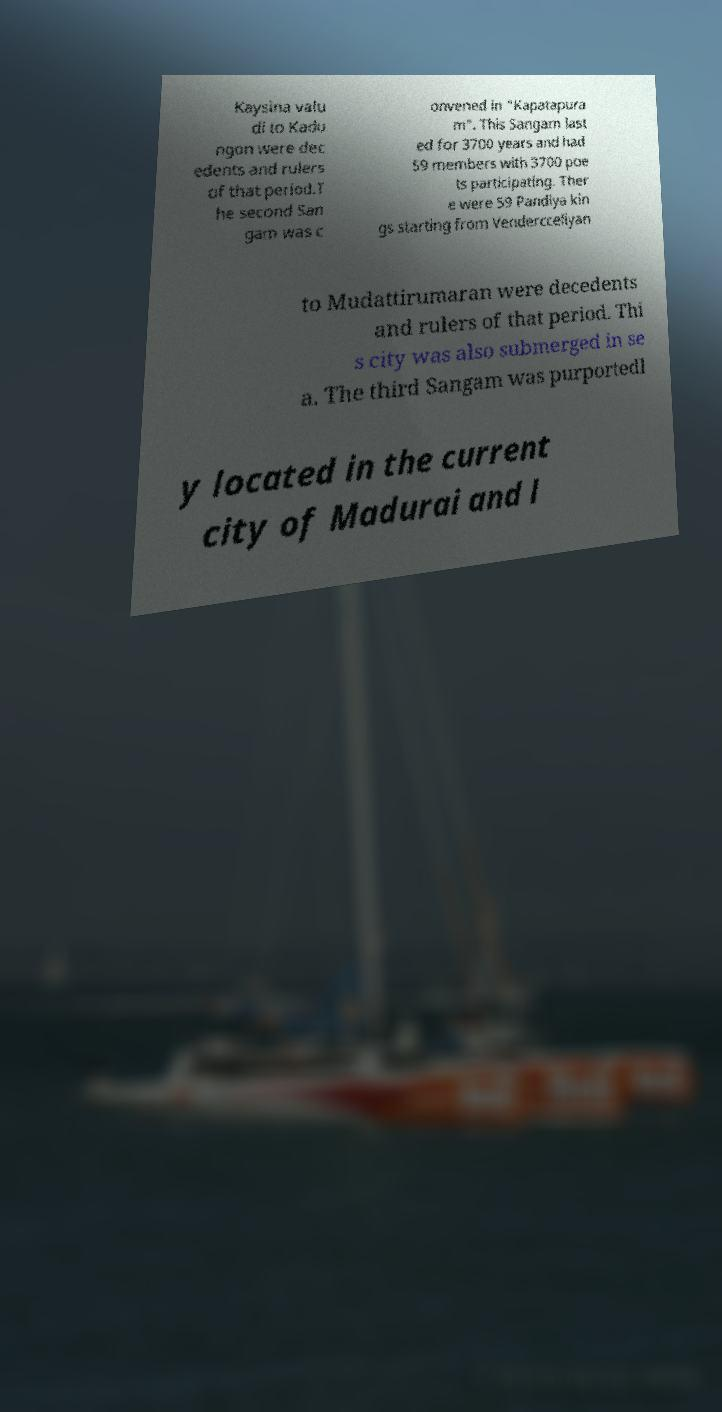For documentation purposes, I need the text within this image transcribed. Could you provide that? Kaysina valu di to Kadu ngon were dec edents and rulers of that period.T he second San gam was c onvened in "Kapatapura m". This Sangam last ed for 3700 years and had 59 members with 3700 poe ts participating. Ther e were 59 Pandiya kin gs starting from Vendercceliyan to Mudattirumaran were decedents and rulers of that period. Thi s city was also submerged in se a. The third Sangam was purportedl y located in the current city of Madurai and l 